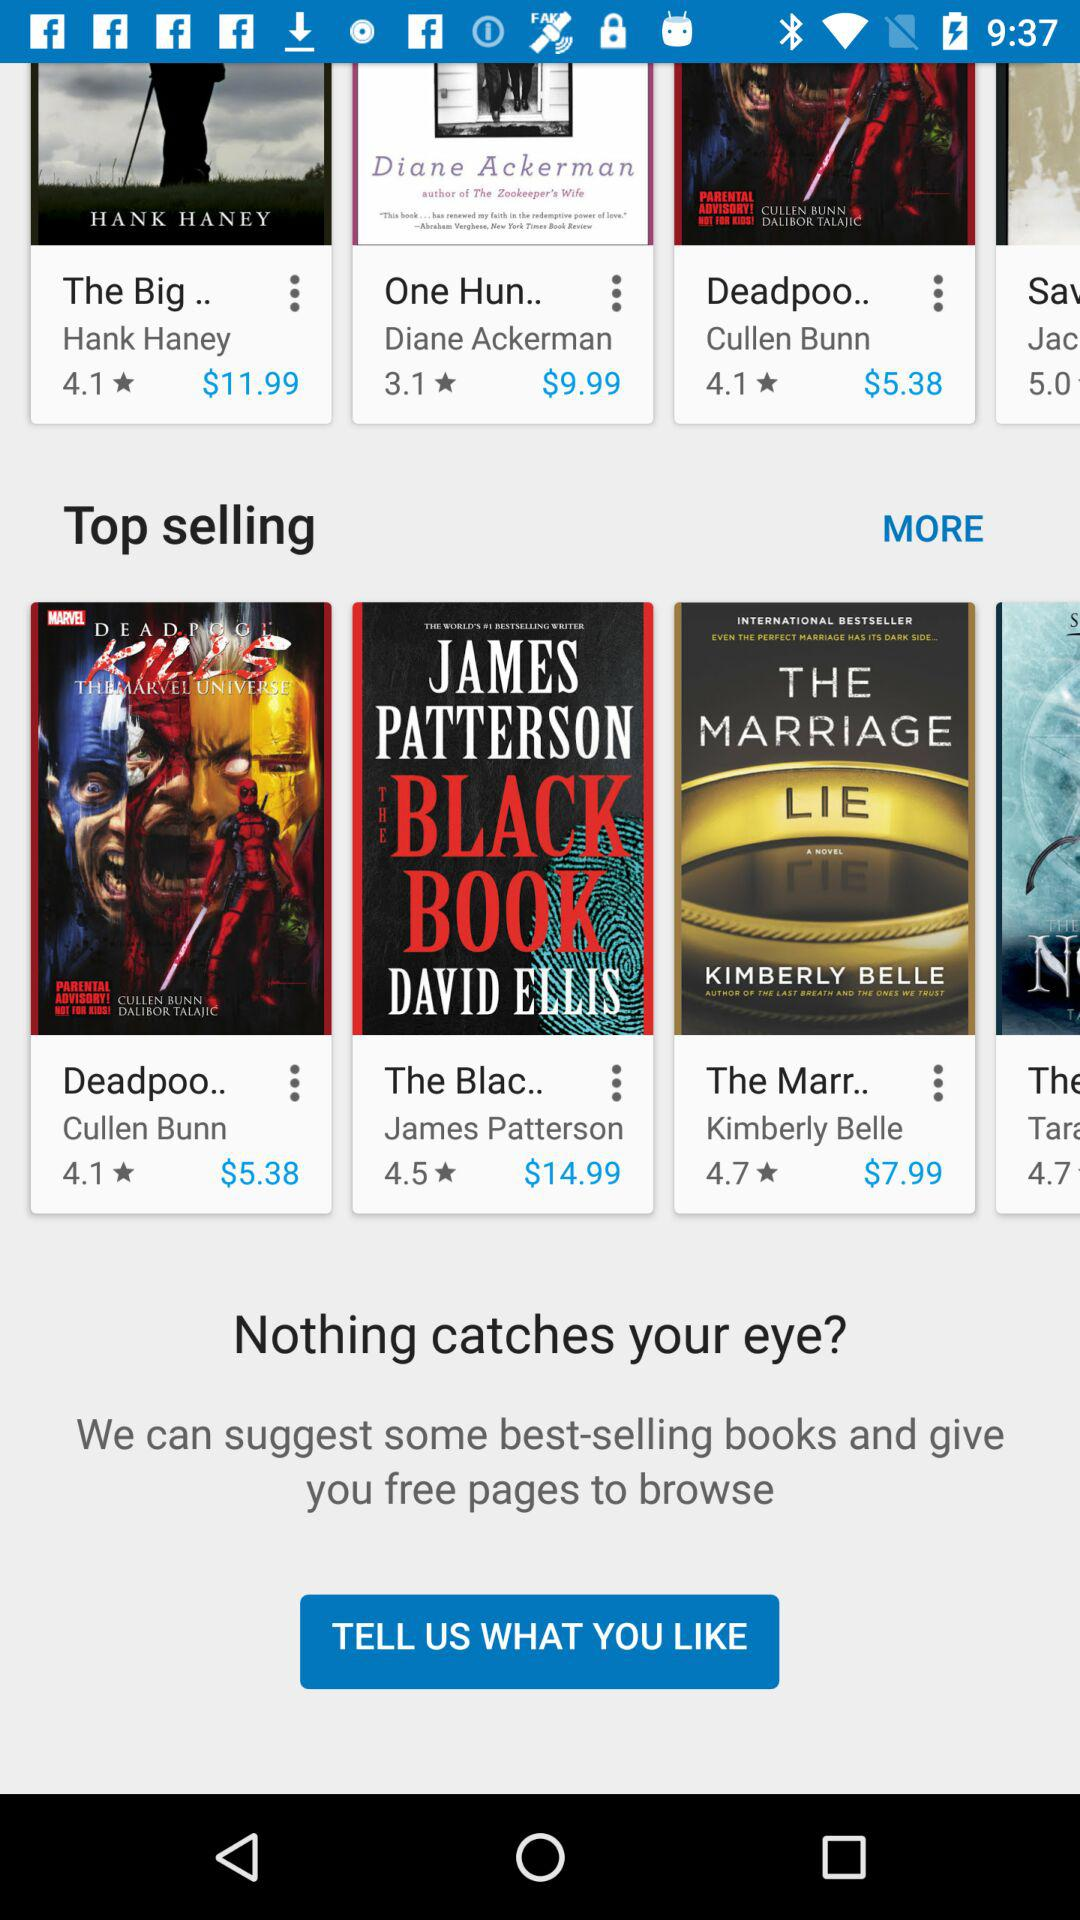What are the top-selling books? The top-selling books are "Deadpoo..", "The Blac.." and "The Marr..". 